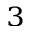<formula> <loc_0><loc_0><loc_500><loc_500>_ { 3 }</formula> 